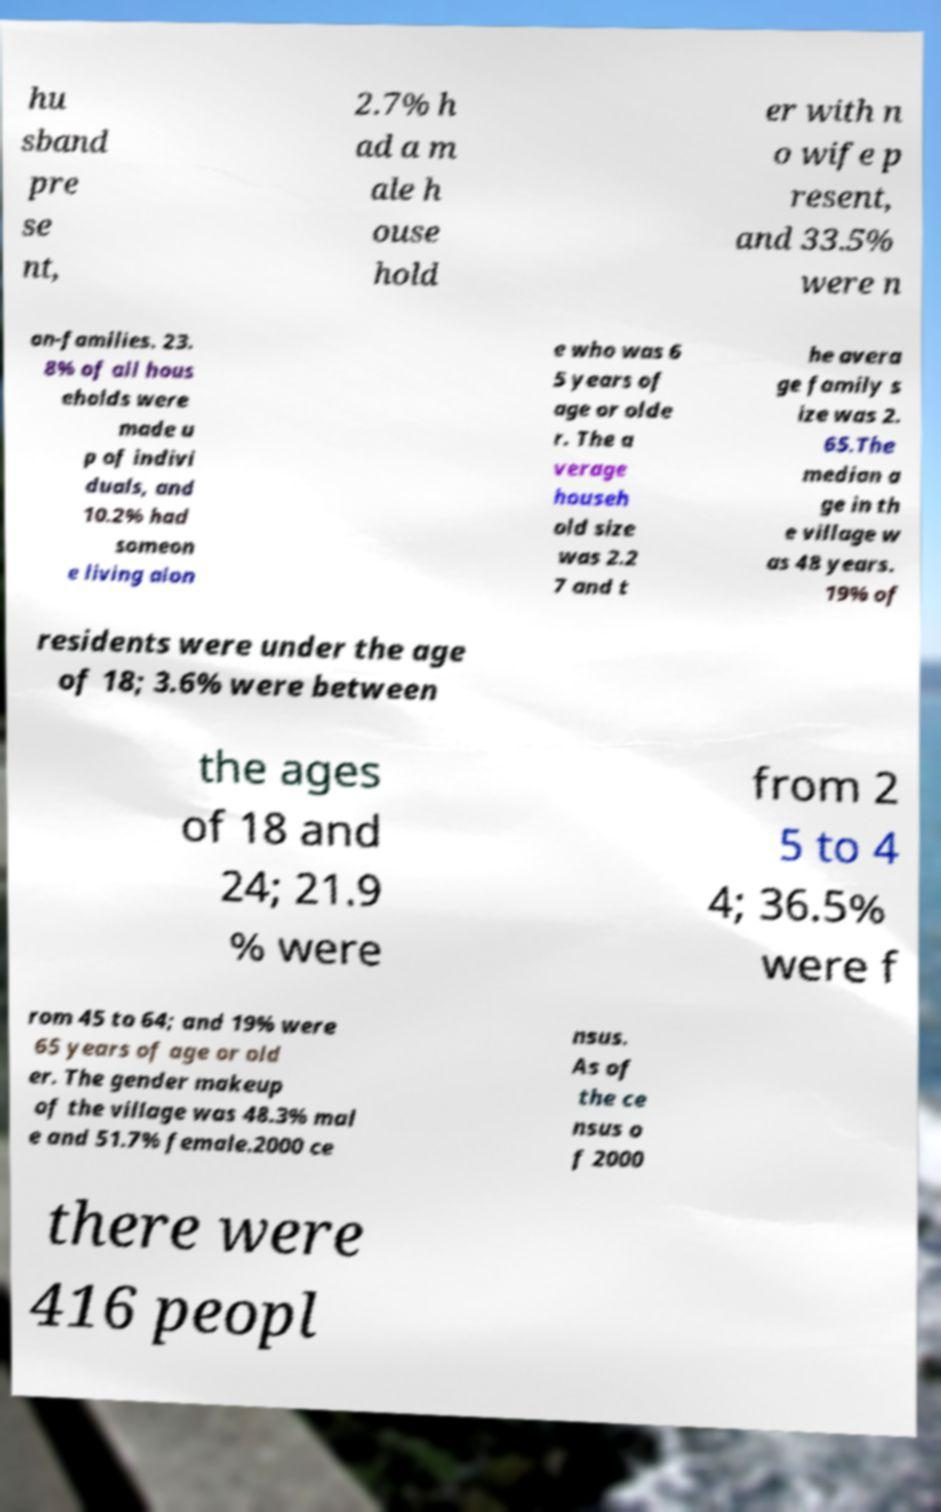What messages or text are displayed in this image? I need them in a readable, typed format. hu sband pre se nt, 2.7% h ad a m ale h ouse hold er with n o wife p resent, and 33.5% were n on-families. 23. 8% of all hous eholds were made u p of indivi duals, and 10.2% had someon e living alon e who was 6 5 years of age or olde r. The a verage househ old size was 2.2 7 and t he avera ge family s ize was 2. 65.The median a ge in th e village w as 48 years. 19% of residents were under the age of 18; 3.6% were between the ages of 18 and 24; 21.9 % were from 2 5 to 4 4; 36.5% were f rom 45 to 64; and 19% were 65 years of age or old er. The gender makeup of the village was 48.3% mal e and 51.7% female.2000 ce nsus. As of the ce nsus o f 2000 there were 416 peopl 